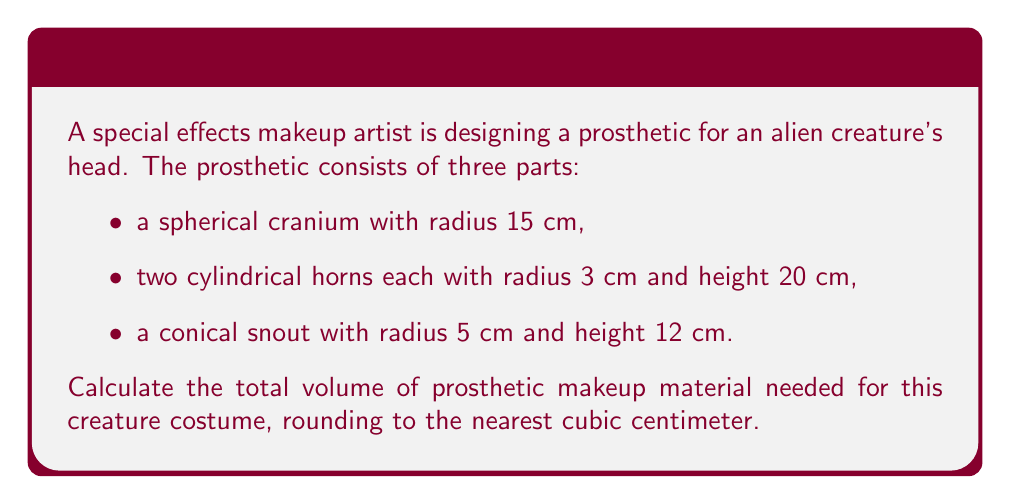What is the answer to this math problem? Let's break this down step-by-step:

1. Calculate the volume of the spherical cranium:
   $$V_{sphere} = \frac{4}{3}\pi r^3$$
   $$V_{sphere} = \frac{4}{3}\pi (15\text{ cm})^3 = 14137.17\text{ cm}^3$$

2. Calculate the volume of one cylindrical horn:
   $$V_{cylinder} = \pi r^2 h$$
   $$V_{cylinder} = \pi (3\text{ cm})^2 (20\text{ cm}) = 565.49\text{ cm}^3$$

3. Calculate the volume of both horns:
   $$V_{horns} = 2 \times 565.49\text{ cm}^3 = 1130.97\text{ cm}^3$$

4. Calculate the volume of the conical snout:
   $$V_{cone} = \frac{1}{3}\pi r^2 h$$
   $$V_{cone} = \frac{1}{3}\pi (5\text{ cm})^2 (12\text{ cm}) = 314.16\text{ cm}^3$$

5. Sum up all the volumes:
   $$V_{total} = V_{sphere} + V_{horns} + V_{cone}$$
   $$V_{total} = 14137.17\text{ cm}^3 + 1130.97\text{ cm}^3 + 314.16\text{ cm}^3$$
   $$V_{total} = 15582.30\text{ cm}^3$$

6. Round to the nearest cubic centimeter:
   $$V_{total} \approx 15582\text{ cm}^3$$
Answer: 15582 cm³ 